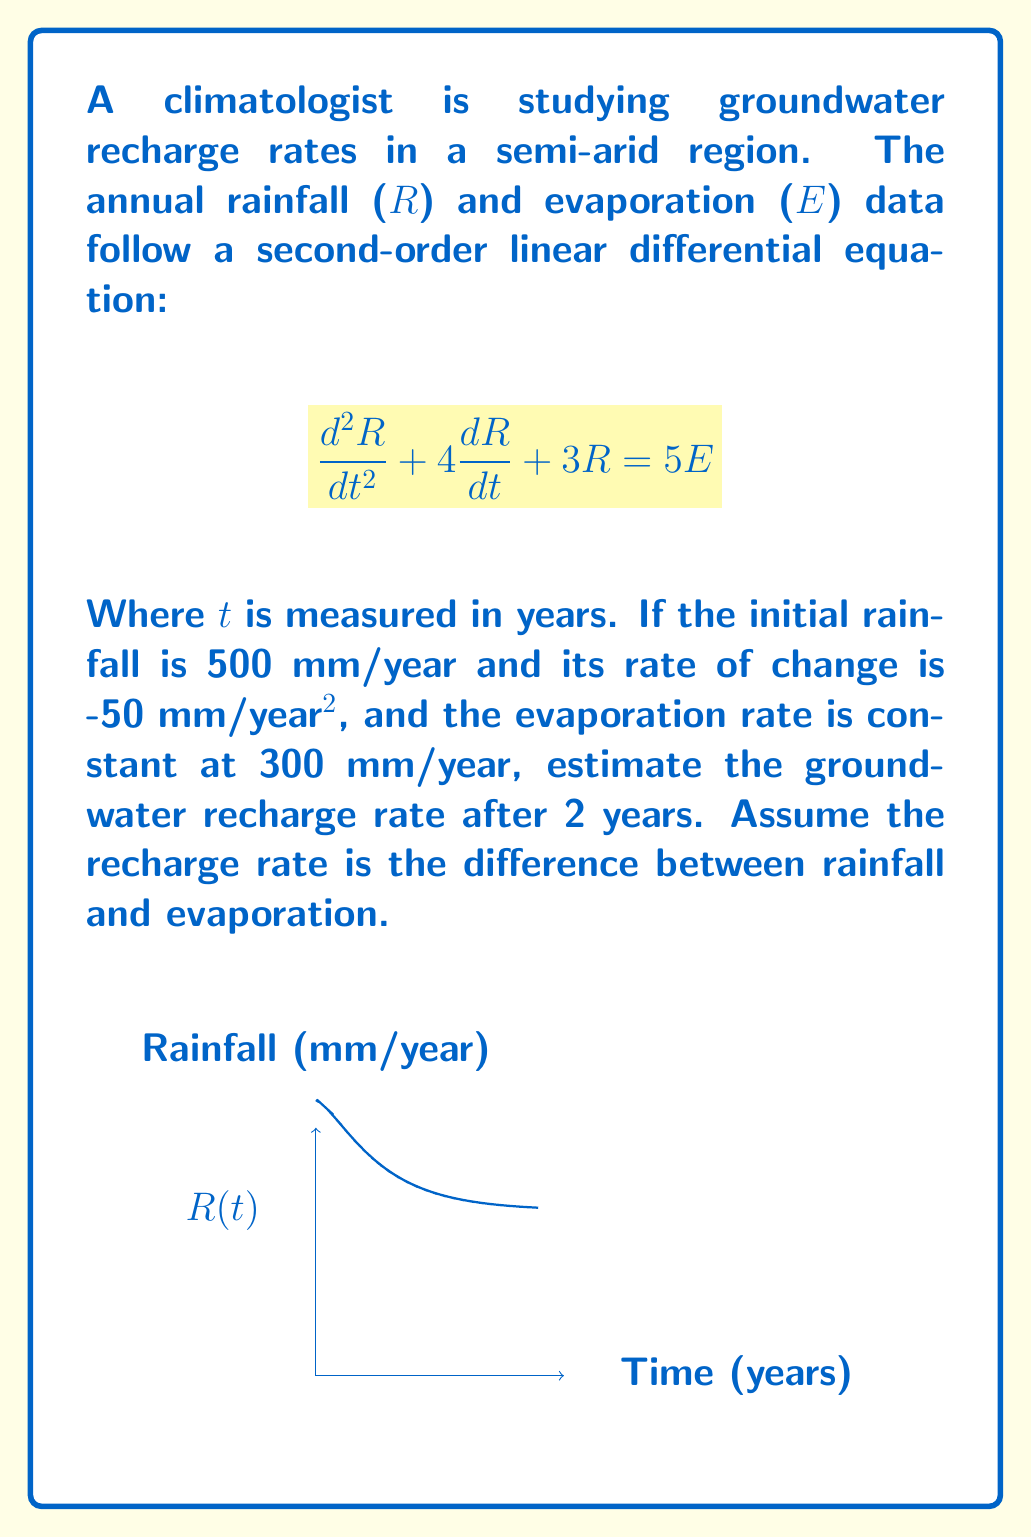Show me your answer to this math problem. 1) First, we need to solve the differential equation. The general solution is:
   $$R(t) = C_1e^{-t} + C_2e^{-3t} + \frac{5E}{3}$$

2) Given E = 300 mm/year, we can simplify:
   $$R(t) = C_1e^{-t} + C_2e^{-3t} + 500$$

3) Using initial conditions:
   R(0) = 500: $C_1 + C_2 = 0$
   R'(0) = -50: $-C_1 - 3C_2 = -50$

4) Solving these equations:
   $C_1 = 275$, $C_2 = -275$

5) Therefore, the rainfall function is:
   $$R(t) = 500 + 275e^{-t} - 275e^{-3t}$$

6) To find R(2), we calculate:
   $$R(2) = 500 + 275e^{-2} - 275e^{-6} \approx 601.65 \text{ mm/year}$$

7) The recharge rate is R(2) - E:
   $$601.65 - 300 = 301.65 \text{ mm/year}$$
Answer: 301.65 mm/year 